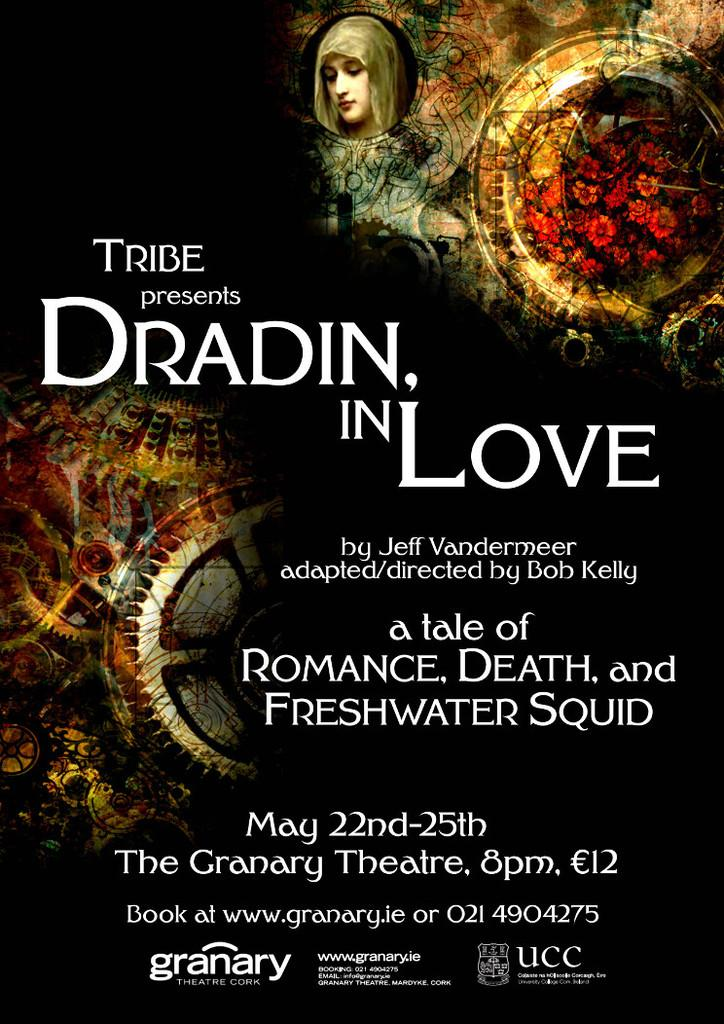What type of visual is the image in question? The image is a poster. What elements can be found on the poster? The poster contains both text and images. How many buckets are depicted in the poster? There is no mention of buckets in the facts provided, so it cannot be determined if any are present in the poster. 